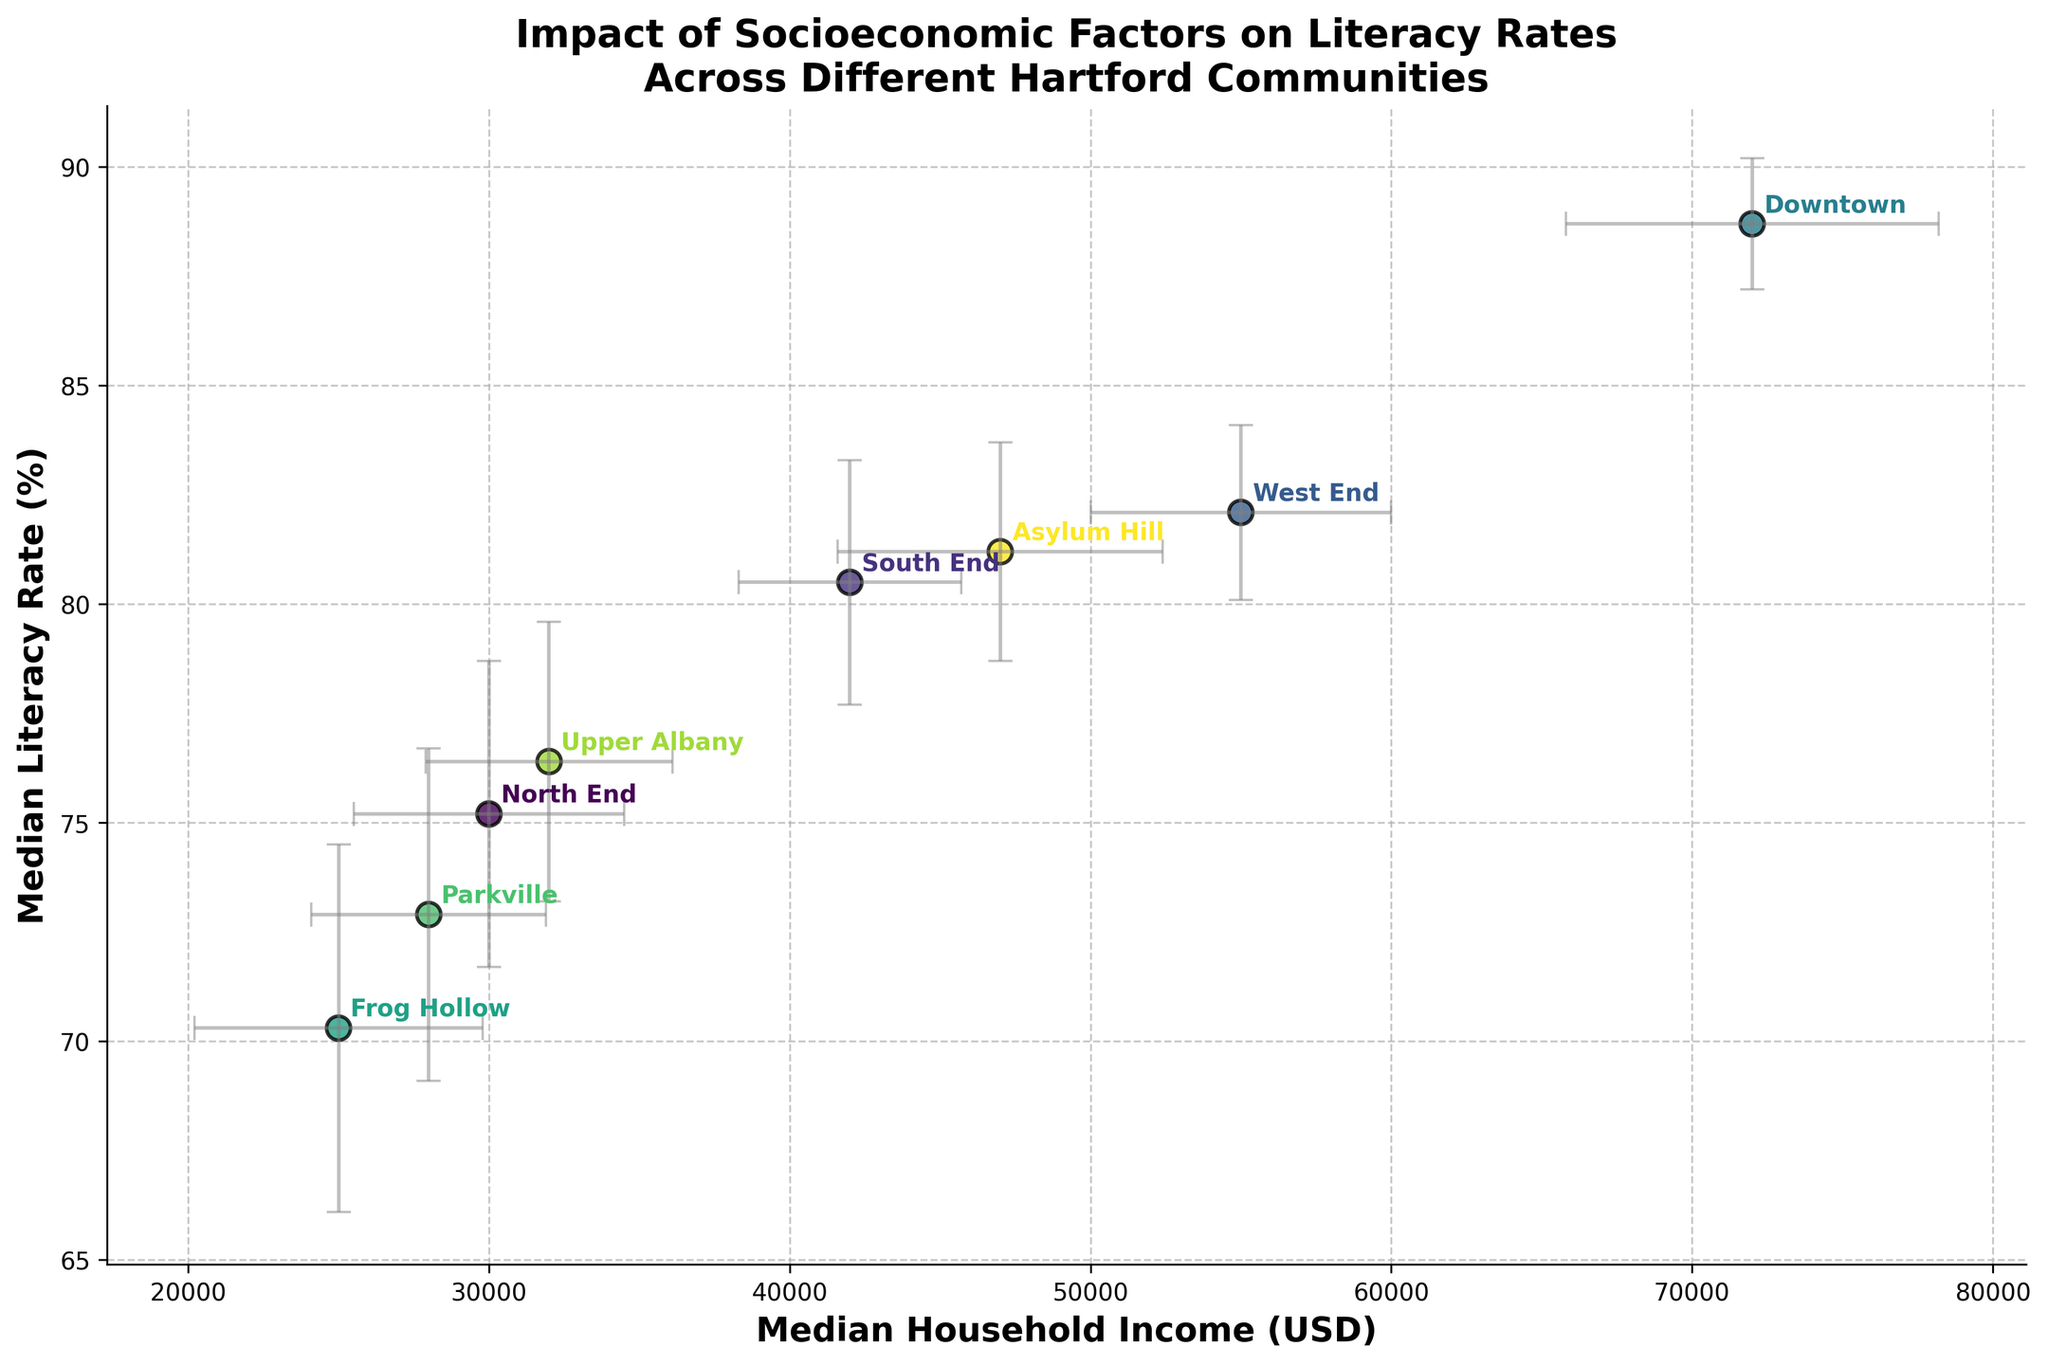How many communities are represented in the plot? Count the number of different annotated communities on the plot.
Answer: 8 What is the title of the plot? Read the title text displayed at the top of the plot.
Answer: Impact of Socioeconomic Factors on Literacy Rates Across Different Hartford Communities Which community has the highest median literacy rate? Locate the highest point on the y-axis and read the corresponding community annotation.
Answer: Downtown What is the difference in median household income between North End and Downtown? Find the x-axis values for North End and Downtown, then subtract the former from the latter (72000 - 30000).
Answer: 42000 USD Which community shows the highest variability in median literacy rate? Identify the community with the largest error bar on the y-axis.
Answer: Frog Hollow How does the median household income of Parkville compare to Upper Albany? Compare the x-axis values of Parkville and Upper Albany to see which is higher.
Answer: Upper Albany has a higher median household income What is the relationship between median household income and literacy rate in Asylum Hill? Locate the point for Asylum Hill and state its approximate x and y values. Then describe if an increase in one results in an increase in the other.
Answer: Positive correlation Which community has the smallest standard deviation in median household income? Identify the smallest error bar on the x-axis.
Answer: South End Is there a general trend between household income and literacy rate visible in the plot? Observe the distribution of points in relation to the axes to see if there's an upward or downward pattern.
Answer: Yes, higher incomes generally correlate with higher literacy rates What is the literacy rate range for the West End based on the error bars? Calculate the range by adding and subtracting the standard deviation from the median literacy rate (82.1 ± 2.0).
Answer: 80.1% to 84.1% 